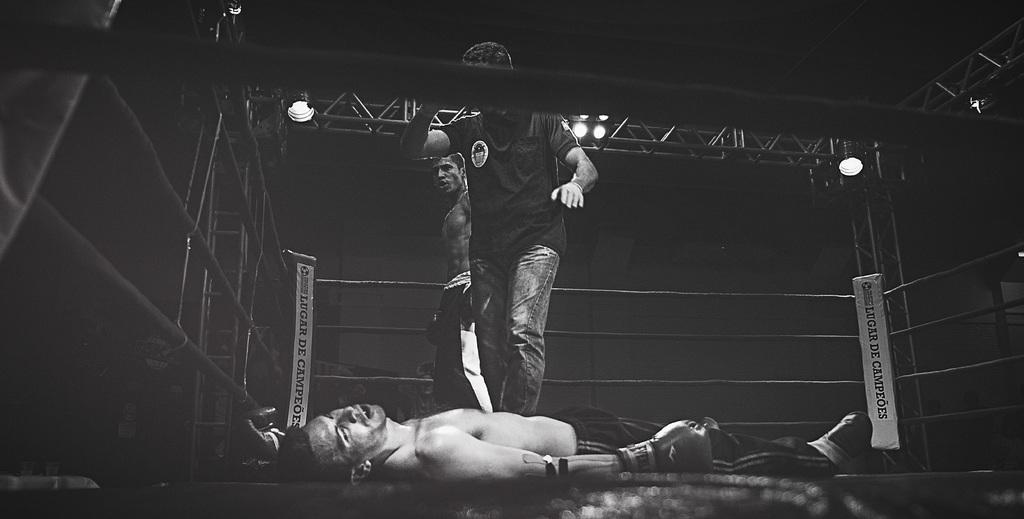What are the people in the image doing? The people in the image are standing in the center. What is the position of the man in the image? The man is lying at the bottom of the image. What can be seen in the background of the image? There are lights and ropes visible in the background. What type of print is the lawyer holding in the image? There is no print or lawyer present in the image. How many lines can be seen in the image? There is no specific mention of lines in the image, so it is not possible to determine the number of lines. 